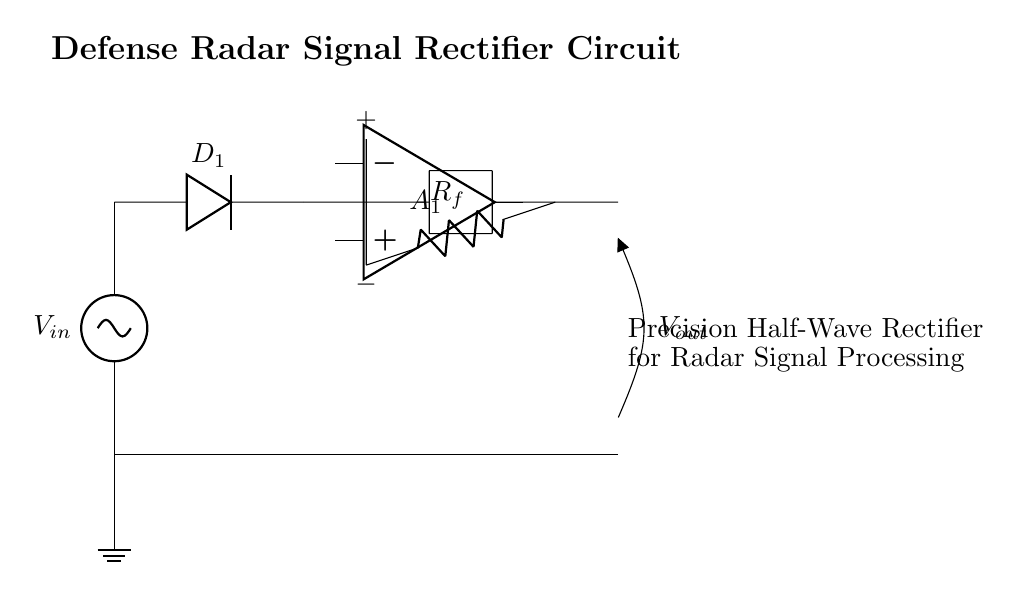What is the input voltage in this circuit? The input voltage is denoted as Vin, shown at the top left of the circuit diagram. It is the voltage source that initiates the operation of the rectifier.
Answer: Vin What type of diode is used in this circuit? The diode labeled D1 is used in the circuit, as indicated in the diagram. It allows current to flow in one direction, characteristic of diodes.
Answer: D1 What is the role of the operational amplifier in this circuit? The operational amplifier, labeled A1, is used to process the input signal and provide a controlled output. It enhances the precision of the rectification process.
Answer: Precision signal processing What is the value of the feedback resistor in this circuit? The resistor labeled Rf is the feedback resistor, which is crucial in setting the gain of the operational amplifier and affecting the rectifier's performance. The specific value is not given in the diagram, indicating it is a design choice.
Answer: Rf Why is this circuit referred to as a precision half-wave rectifier? The circuit is termed a precision half-wave rectifier because it precisely rectifies only the positive half-cycles of the input signal, thanks to the combination of the diode and operational amplifier. This precision is critical for radar signal processing applications.
Answer: Precision half-wave rectification What distinguishes this rectifier from a standard half-wave rectifier? This rectifier includes an operational amplifier, which greatly improves accuracy and performance over a standard half-wave rectifier that uses only a diode. It allows for lower voltage input signals to be effectively processed.
Answer: Operational amplifier inclusion What type of application is this circuit primarily designed for? This circuit is specifically designed for radar signal processing in defense systems, as indicated by the label on the right side of the circuit. This application requires high accuracy in signal rectification.
Answer: Radar signal processing 